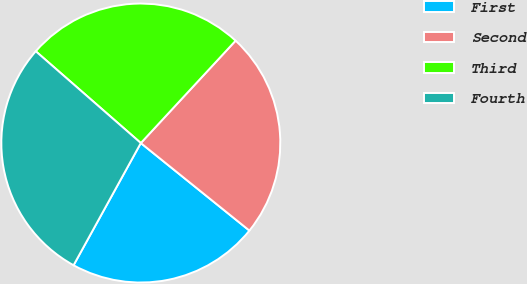<chart> <loc_0><loc_0><loc_500><loc_500><pie_chart><fcel>First<fcel>Second<fcel>Third<fcel>Fourth<nl><fcel>22.21%<fcel>23.91%<fcel>25.46%<fcel>28.42%<nl></chart> 